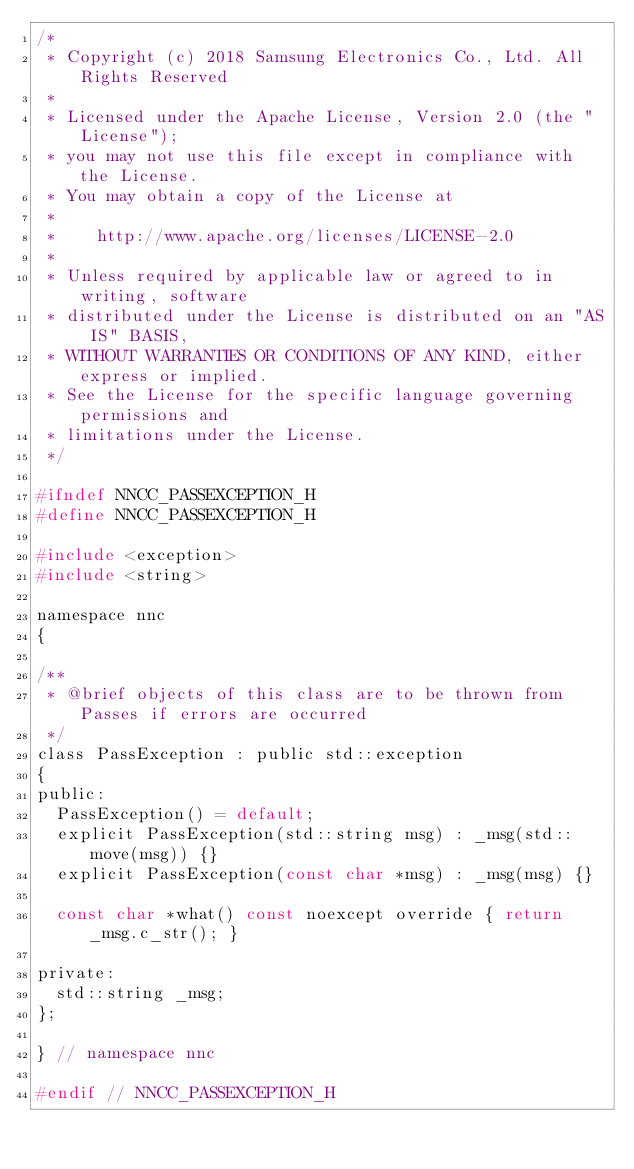Convert code to text. <code><loc_0><loc_0><loc_500><loc_500><_C_>/*
 * Copyright (c) 2018 Samsung Electronics Co., Ltd. All Rights Reserved
 *
 * Licensed under the Apache License, Version 2.0 (the "License");
 * you may not use this file except in compliance with the License.
 * You may obtain a copy of the License at
 *
 *    http://www.apache.org/licenses/LICENSE-2.0
 *
 * Unless required by applicable law or agreed to in writing, software
 * distributed under the License is distributed on an "AS IS" BASIS,
 * WITHOUT WARRANTIES OR CONDITIONS OF ANY KIND, either express or implied.
 * See the License for the specific language governing permissions and
 * limitations under the License.
 */

#ifndef NNCC_PASSEXCEPTION_H
#define NNCC_PASSEXCEPTION_H

#include <exception>
#include <string>

namespace nnc
{

/**
 * @brief objects of this class are to be thrown from Passes if errors are occurred
 */
class PassException : public std::exception
{
public:
  PassException() = default;
  explicit PassException(std::string msg) : _msg(std::move(msg)) {}
  explicit PassException(const char *msg) : _msg(msg) {}

  const char *what() const noexcept override { return _msg.c_str(); }

private:
  std::string _msg;
};

} // namespace nnc

#endif // NNCC_PASSEXCEPTION_H
</code> 